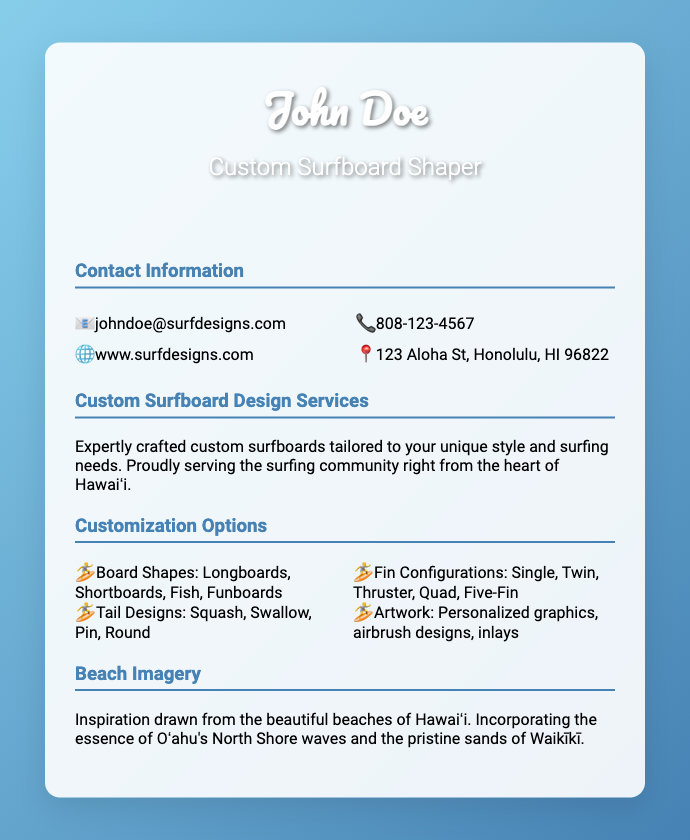What is the name of the surfboard shaper? The name listed on the business card is "John Doe".
Answer: John Doe What is the email address provided? The email address mentioned in the contact information is for inquiries and communication.
Answer: johndoe@surfdesigns.com What types of surfboard shapes are offered? The document lists different types of board shapes available for customization.
Answer: Longboards, Shortboards, Fish, Funboards Where is the surfboard shaper located? The address provided indicates the physical location of the business.
Answer: 123 Aloha St, Honolulu, HI 96822 What is the primary service mentioned? The card describes the main service offered by the surfboard shaper.
Answer: Custom surfboard design services How many fin configurations are there to choose from? The customization options include various fin configurations listed in the document.
Answer: Five What is the theme of the beach imagery provided? The text describes the source of inspiration for the surfboards based on local features.
Answer: Beautiful beaches of Hawaiʻi What is the phone number for contact? The document includes a phone number for direct communication.
Answer: 808-123-4567 What type of graphics are included in the customization options? The customization includes personal touches that enhance the surfboard's design.
Answer: Personalized graphics, airbrush designs, inlays 